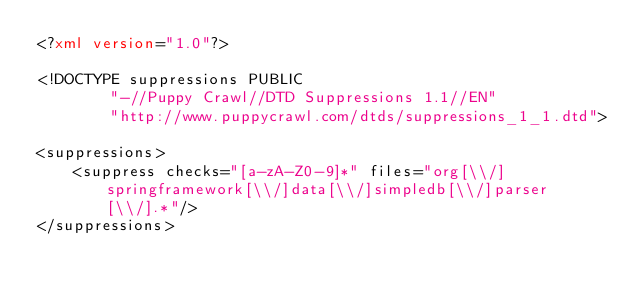Convert code to text. <code><loc_0><loc_0><loc_500><loc_500><_XML_><?xml version="1.0"?>

<!DOCTYPE suppressions PUBLIC
        "-//Puppy Crawl//DTD Suppressions 1.1//EN"
        "http://www.puppycrawl.com/dtds/suppressions_1_1.dtd">

<suppressions>
    <suppress checks="[a-zA-Z0-9]*" files="org[\\/]springframework[\\/]data[\\/]simpledb[\\/]parser[\\/].*"/>
</suppressions></code> 